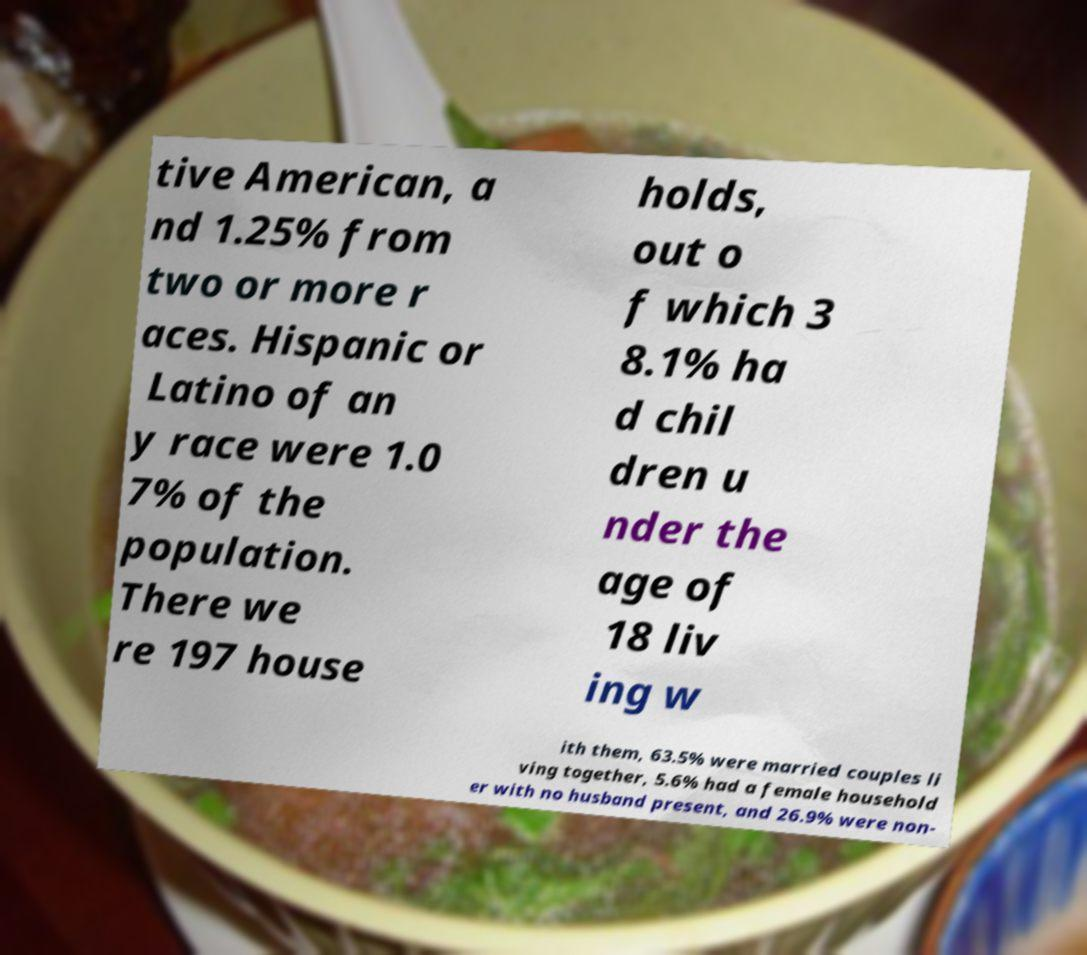Can you accurately transcribe the text from the provided image for me? tive American, a nd 1.25% from two or more r aces. Hispanic or Latino of an y race were 1.0 7% of the population. There we re 197 house holds, out o f which 3 8.1% ha d chil dren u nder the age of 18 liv ing w ith them, 63.5% were married couples li ving together, 5.6% had a female household er with no husband present, and 26.9% were non- 